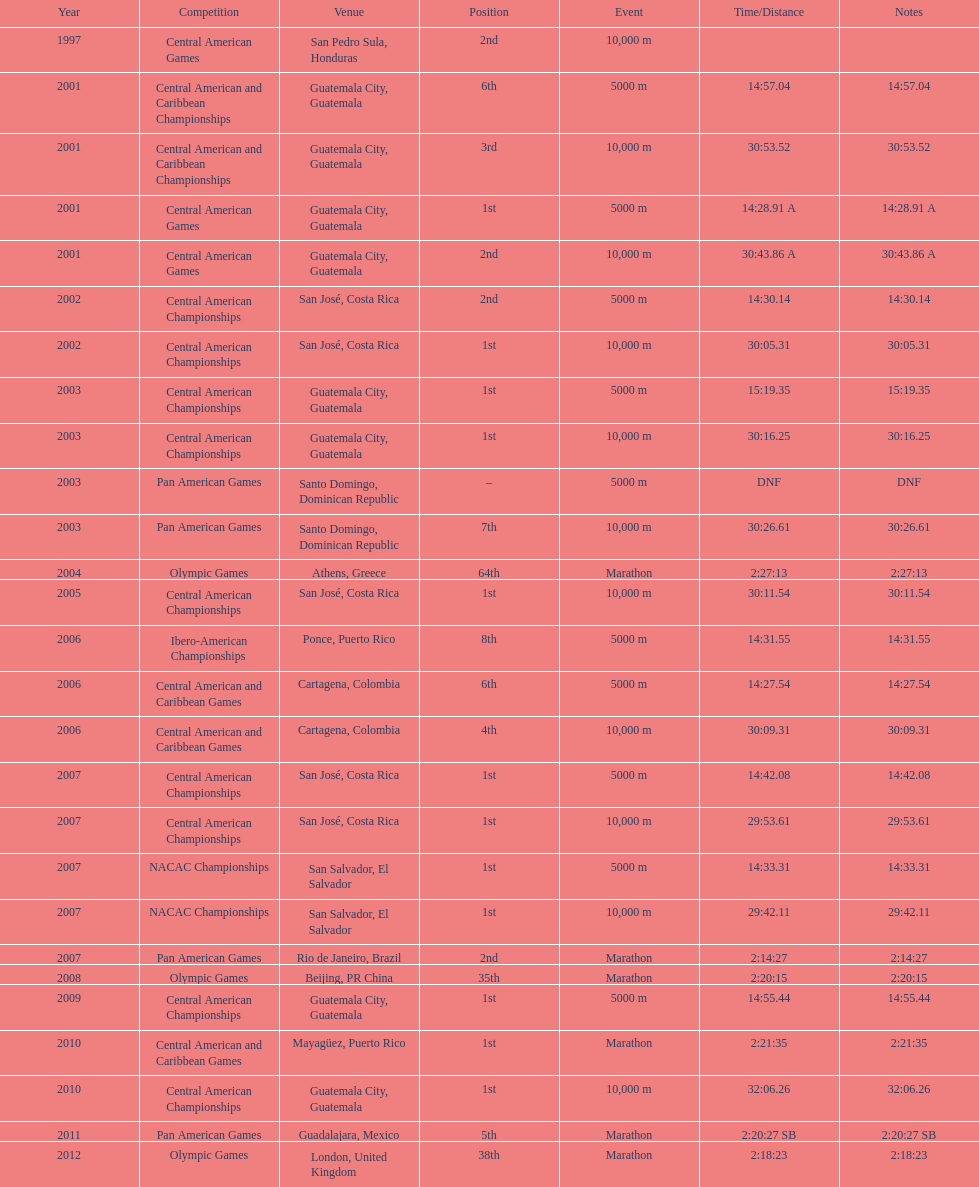Tell me the number of times they competed in guatamala. 5. 